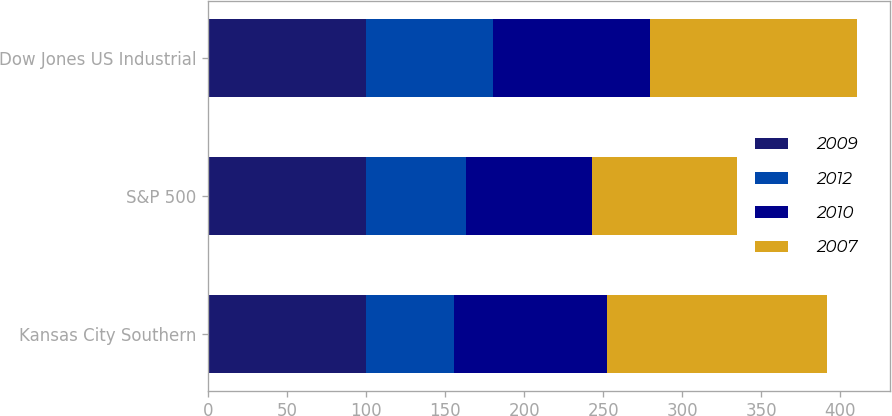<chart> <loc_0><loc_0><loc_500><loc_500><stacked_bar_chart><ecel><fcel>Kansas City Southern<fcel>S&P 500<fcel>Dow Jones US Industrial<nl><fcel>2009<fcel>100<fcel>100<fcel>100<nl><fcel>2012<fcel>55.49<fcel>63<fcel>80.43<nl><fcel>2010<fcel>96.97<fcel>79.67<fcel>98.93<nl><fcel>2007<fcel>139.41<fcel>91.67<fcel>131.35<nl></chart> 